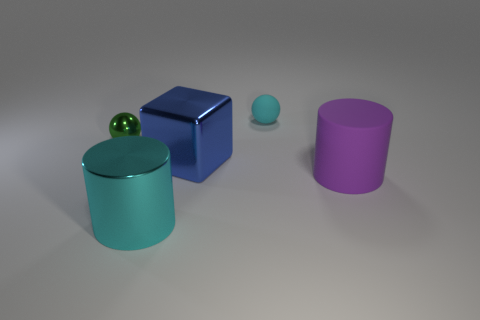Add 4 small blue metal blocks. How many objects exist? 9 Subtract all blocks. How many objects are left? 4 Subtract 1 green spheres. How many objects are left? 4 Subtract all big purple rubber objects. Subtract all blue metal cubes. How many objects are left? 3 Add 4 metallic blocks. How many metallic blocks are left? 5 Add 1 big purple metal things. How many big purple metal things exist? 1 